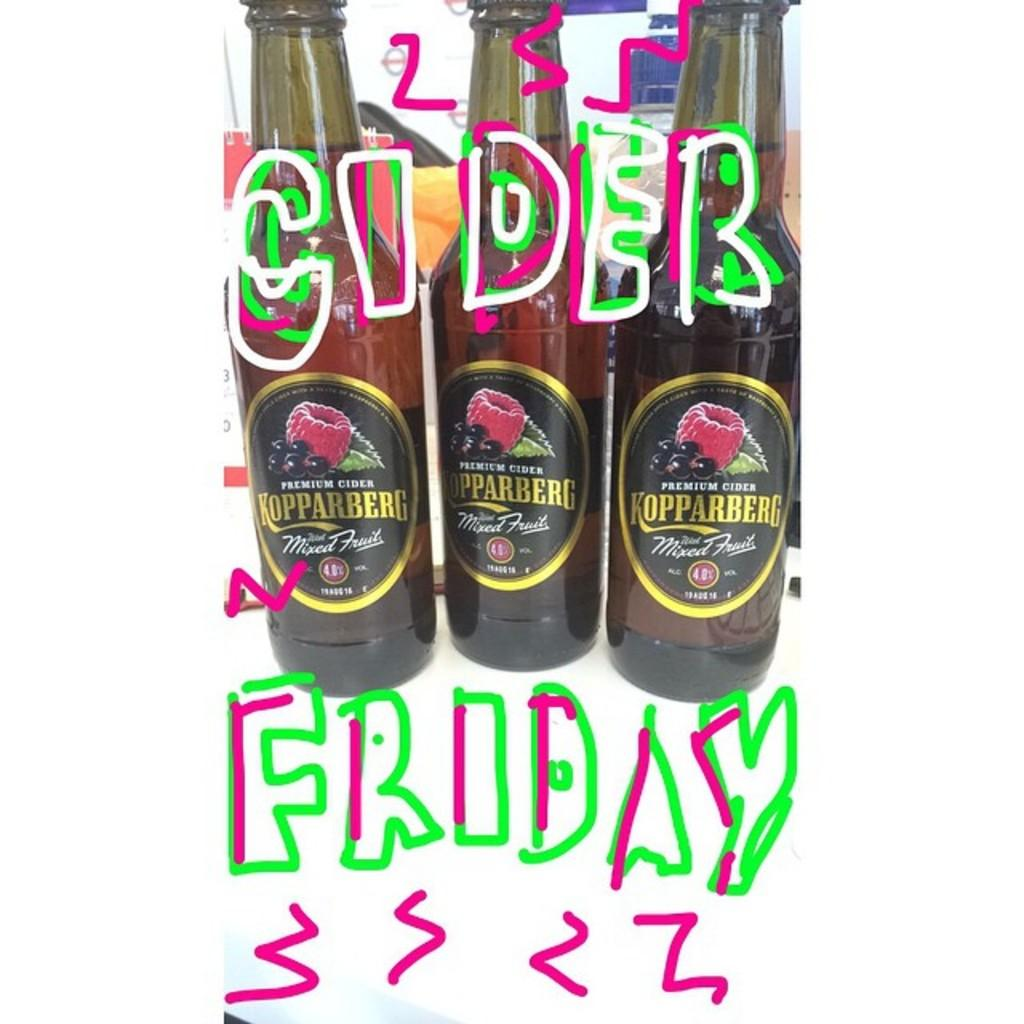<image>
Share a concise interpretation of the image provided. the word Friday is on some of the bottles 